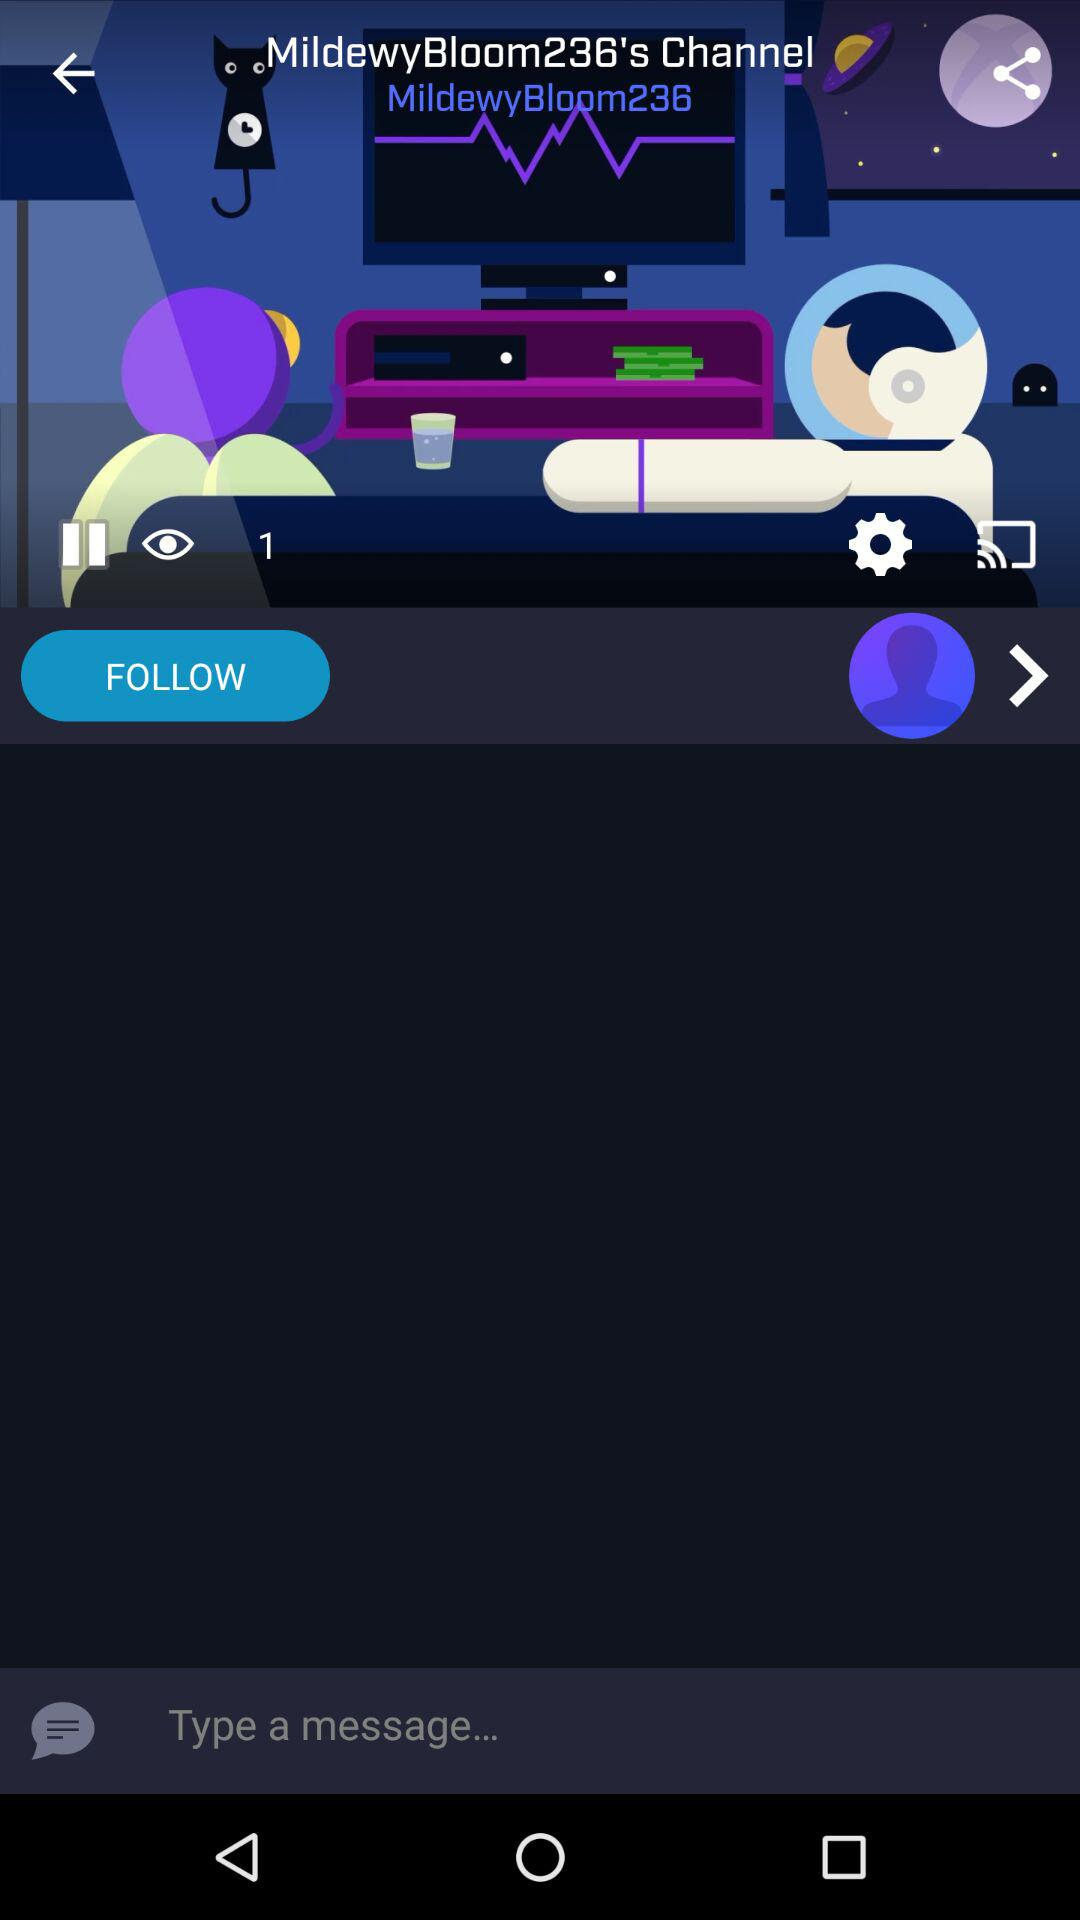What is the channel name? The channel name is "MildewyBloom236". 